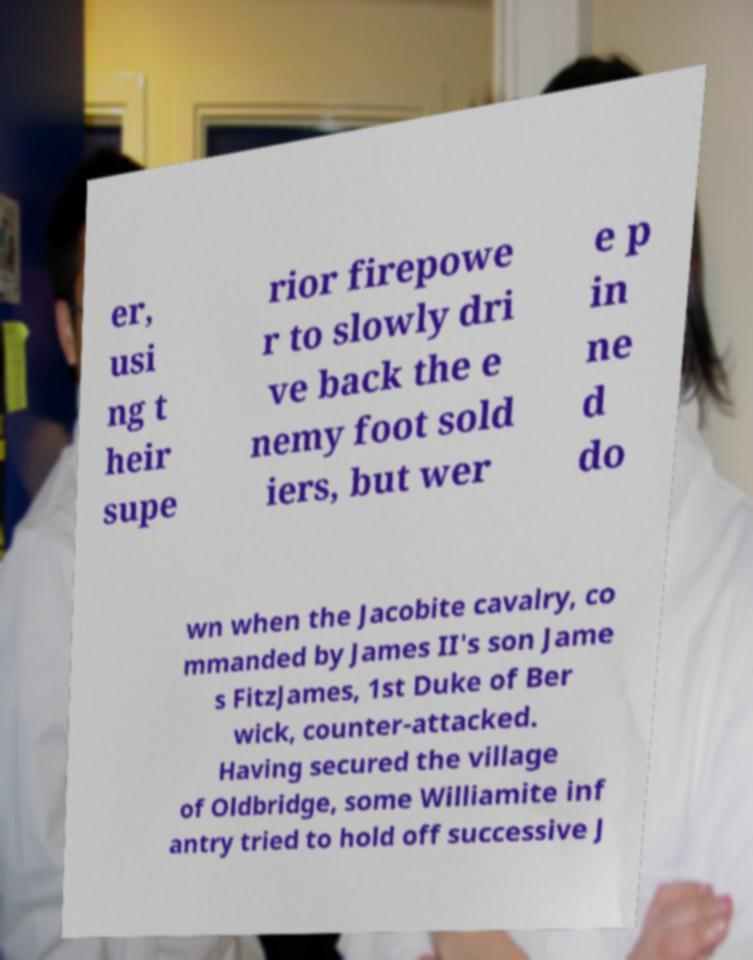Can you read and provide the text displayed in the image?This photo seems to have some interesting text. Can you extract and type it out for me? er, usi ng t heir supe rior firepowe r to slowly dri ve back the e nemy foot sold iers, but wer e p in ne d do wn when the Jacobite cavalry, co mmanded by James II's son Jame s FitzJames, 1st Duke of Ber wick, counter-attacked. Having secured the village of Oldbridge, some Williamite inf antry tried to hold off successive J 